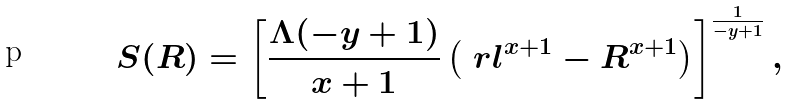<formula> <loc_0><loc_0><loc_500><loc_500>S ( R ) = \left [ \frac { \Lambda ( - y + 1 ) } { x + 1 } \left ( \ r l ^ { x + 1 } - R ^ { x + 1 } \right ) \right ] ^ { \frac { 1 } { - y + 1 } } ,</formula> 